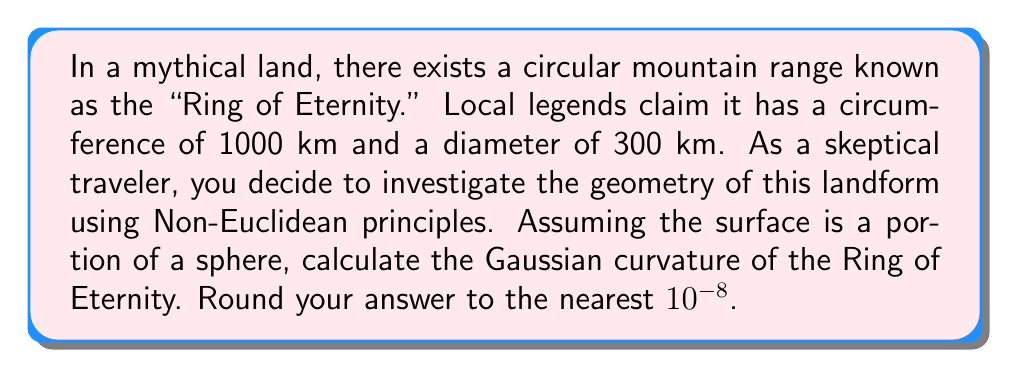Give your solution to this math problem. To determine the Gaussian curvature of the Ring of Eternity, we'll follow these steps:

1) In Euclidean geometry, the ratio of circumference to diameter for a circle is always $\pi$. However, in this case:

   $\frac{\text{Circumference}}{\text{Diameter}} = \frac{1000}{300} \approx 3.33 < \pi$

   This suggests we're dealing with a positively curved surface (like a sphere).

2) Let's denote the radius of the sphere as $R$. The circumference of the Ring of Eternity forms a great circle on this sphere. The formula for the circumference of a great circle is:

   $C = 2\pi R$

3) Substituting the given circumference:

   $1000 = 2\pi R$
   $R = \frac{1000}{2\pi} \approx 159.15$ km

4) Now, let's consider the "diameter" of 300 km. This is actually the length of an arc on the sphere. The formula for arc length is:

   $s = R\theta$

   where $\theta$ is the central angle in radians.

5) Substituting our values:

   $300 = 159.15\theta$
   $\theta = \frac{300}{159.15} \approx 1.8849$ radians

6) This angle should correspond to $\pi$ radians if the surface were flat. The difference indicates the curvature of the surface.

7) The Gaussian curvature of a sphere is given by:

   $K = \frac{1}{R^2}$

8) Substituting our calculated $R$:

   $K = \frac{1}{(159.15)^2} \approx 0.00003944$ km^-2

9) Converting to m^-2:

   $K \approx 3.944 * 10^{-8}$ m^-2

10) Rounding to the nearest $10^{-8}$:

    $K \approx 3.9 * 10^{-8}$ m^-2
Answer: $3.9 * 10^{-8}$ m^-2 